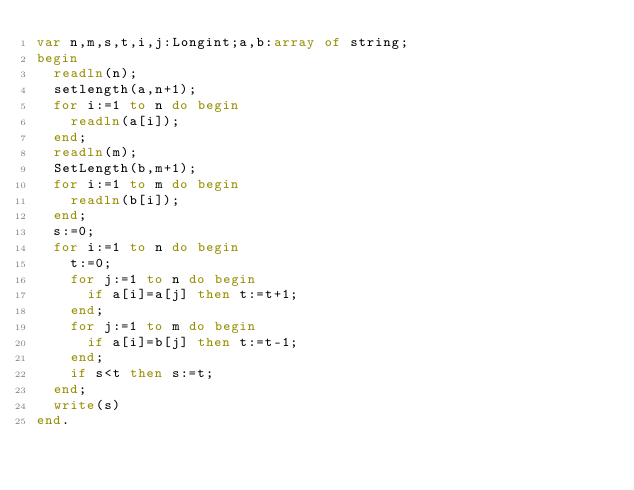<code> <loc_0><loc_0><loc_500><loc_500><_Pascal_>var n,m,s,t,i,j:Longint;a,b:array of string;
begin
	readln(n);
	setlength(a,n+1);
	for i:=1 to n do begin
		readln(a[i]);
	end;
	readln(m);
	SetLength(b,m+1);
	for i:=1 to m do begin
		readln(b[i]);
	end;
	s:=0;
	for i:=1 to n do begin
		t:=0;
		for j:=1 to n do begin
			if a[i]=a[j] then t:=t+1;
		end;
		for j:=1 to m do begin
			if a[i]=b[j] then t:=t-1;
		end;
		if s<t then s:=t;
	end;
	write(s)
end.
</code> 